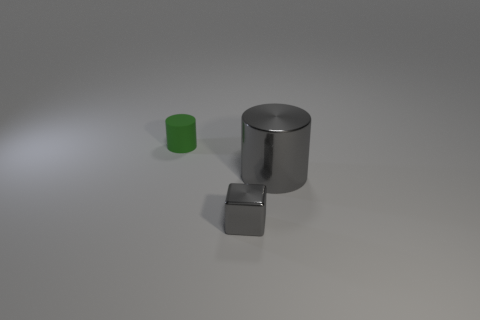Is the color of the cylinder to the right of the tiny cylinder the same as the cylinder that is to the left of the big gray metal cylinder?
Offer a terse response. No. Are there any small gray metal cubes on the left side of the tiny green rubber thing?
Your response must be concise. No. There is a thing that is behind the small metal block and left of the large gray cylinder; what is it made of?
Your answer should be compact. Rubber. Is the gray object that is left of the large cylinder made of the same material as the big gray cylinder?
Offer a terse response. Yes. What is the small gray block made of?
Ensure brevity in your answer.  Metal. What is the size of the cylinder on the left side of the gray metal cube?
Your answer should be very brief. Small. Is there anything else that is the same color as the big object?
Keep it short and to the point. Yes. Is there a gray metal cube that is behind the tiny green matte thing that is behind the metal object in front of the large gray metallic cylinder?
Ensure brevity in your answer.  No. There is a thing to the right of the tiny gray metallic cube; is its color the same as the tiny metallic thing?
Provide a succinct answer. Yes. How many cylinders are either red metal objects or small green rubber objects?
Give a very brief answer. 1. 